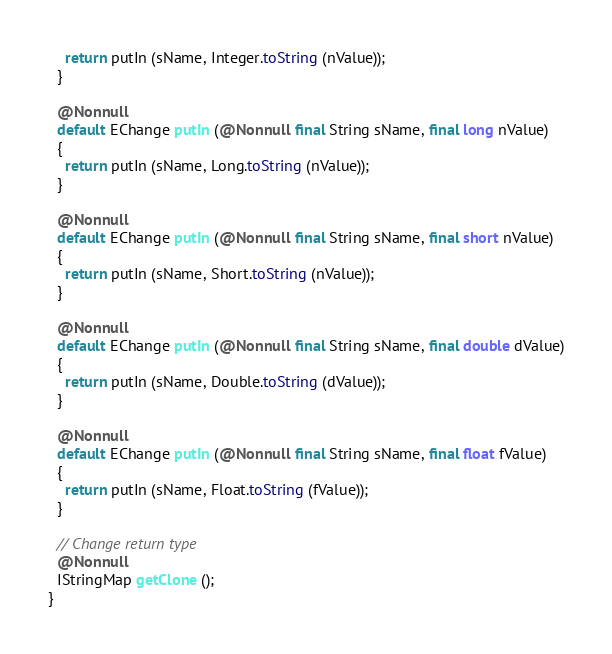Convert code to text. <code><loc_0><loc_0><loc_500><loc_500><_Java_>    return putIn (sName, Integer.toString (nValue));
  }

  @Nonnull
  default EChange putIn (@Nonnull final String sName, final long nValue)
  {
    return putIn (sName, Long.toString (nValue));
  }

  @Nonnull
  default EChange putIn (@Nonnull final String sName, final short nValue)
  {
    return putIn (sName, Short.toString (nValue));
  }

  @Nonnull
  default EChange putIn (@Nonnull final String sName, final double dValue)
  {
    return putIn (sName, Double.toString (dValue));
  }

  @Nonnull
  default EChange putIn (@Nonnull final String sName, final float fValue)
  {
    return putIn (sName, Float.toString (fValue));
  }

  // Change return type
  @Nonnull
  IStringMap getClone ();
}
</code> 